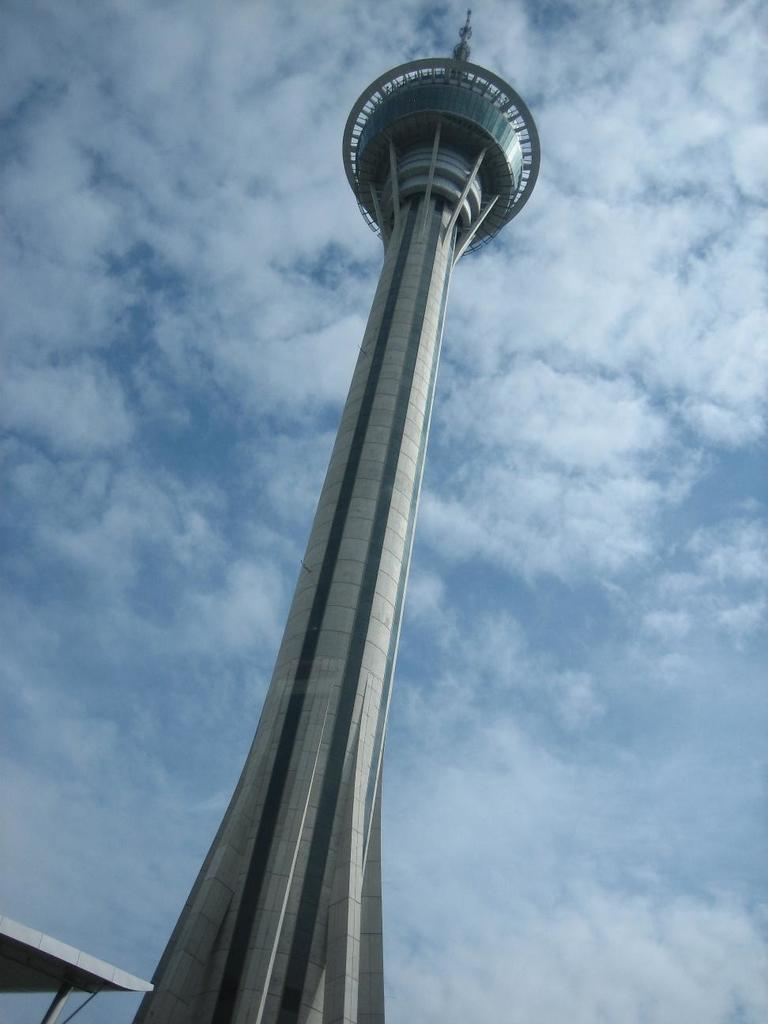What is the main structure in the image? There is a tower in the image. Where is the tower located? The tower is on the ground. What can be seen above the tower in the image? The sky is visible in the image. What is the condition of the sky in the image? The sky is full of clouds. How many horses are present in the image? There are no horses present in the image; it features a tower on the ground with a cloudy sky. What type of basket is being used by the governor in the image? There is no governor or basket present in the image. 